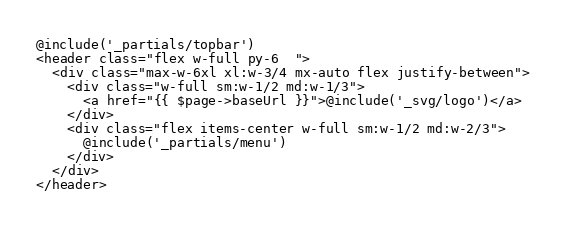Convert code to text. <code><loc_0><loc_0><loc_500><loc_500><_PHP_>@include('_partials/topbar')
<header class="flex w-full py-6  ">
  <div class="max-w-6xl xl:w-3/4 mx-auto flex justify-between">
    <div class="w-full sm:w-1/2 md:w-1/3">
      <a href="{{ $page->baseUrl }}">@include('_svg/logo')</a>
    </div>
    <div class="flex items-center w-full sm:w-1/2 md:w-2/3">
      @include('_partials/menu')
    </div>
  </div>
</header></code> 